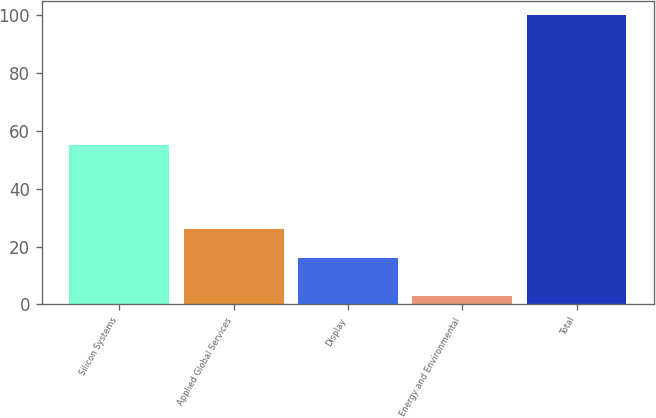Convert chart to OTSL. <chart><loc_0><loc_0><loc_500><loc_500><bar_chart><fcel>Silicon Systems<fcel>Applied Global Services<fcel>Display<fcel>Energy and Environmental<fcel>Total<nl><fcel>55<fcel>26<fcel>16<fcel>3<fcel>100<nl></chart> 